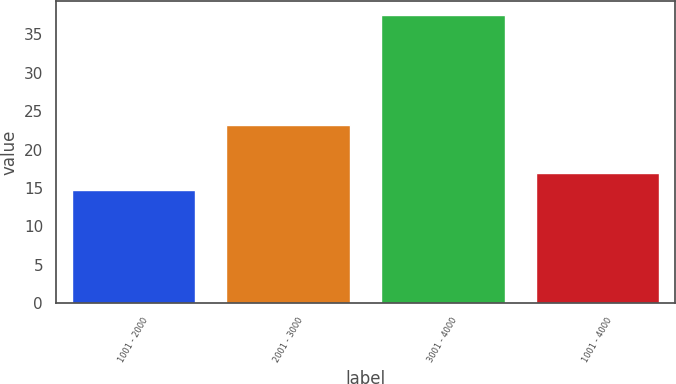<chart> <loc_0><loc_0><loc_500><loc_500><bar_chart><fcel>1001 - 2000<fcel>2001 - 3000<fcel>3001 - 4000<fcel>1001 - 4000<nl><fcel>14.71<fcel>23.15<fcel>37.5<fcel>16.99<nl></chart> 